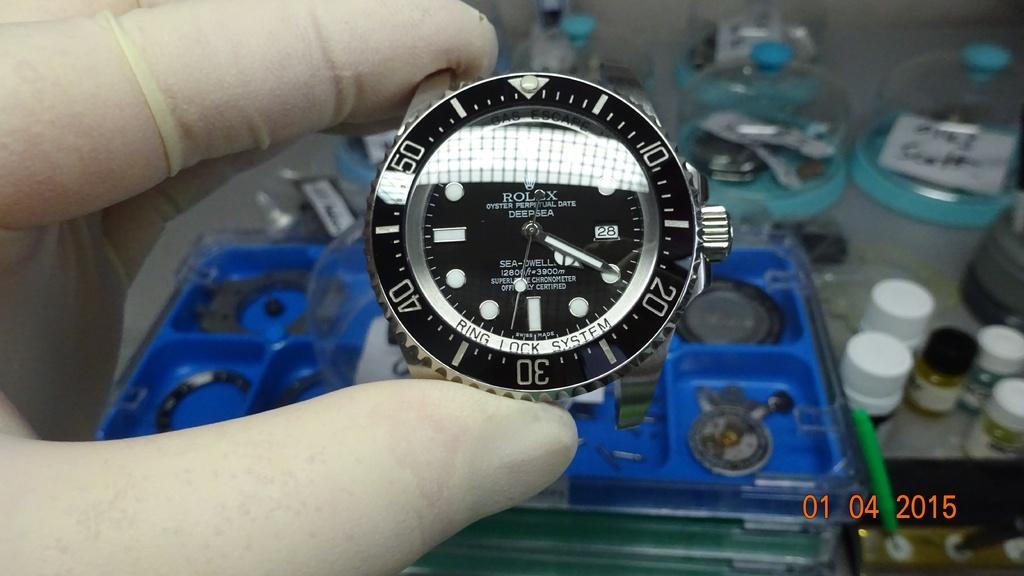<image>
Render a clear and concise summary of the photo. Person holding a clock which says ROLEX on the face. 